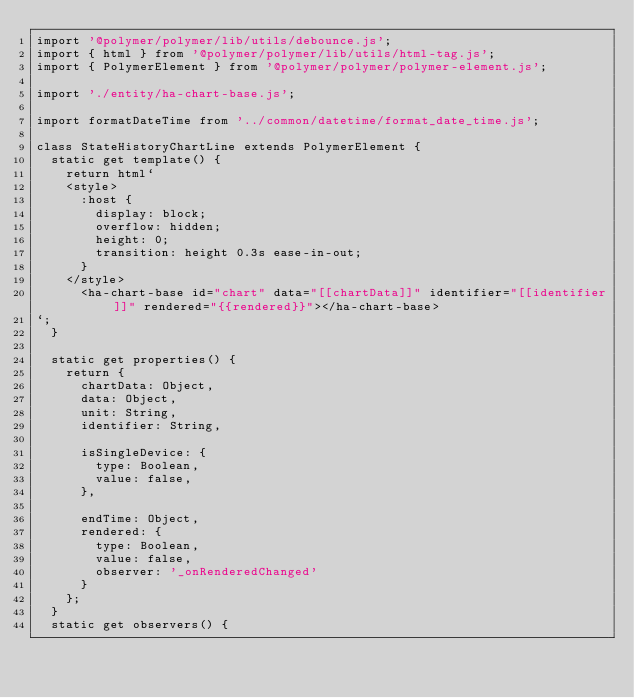<code> <loc_0><loc_0><loc_500><loc_500><_JavaScript_>import '@polymer/polymer/lib/utils/debounce.js';
import { html } from '@polymer/polymer/lib/utils/html-tag.js';
import { PolymerElement } from '@polymer/polymer/polymer-element.js';

import './entity/ha-chart-base.js';

import formatDateTime from '../common/datetime/format_date_time.js';

class StateHistoryChartLine extends PolymerElement {
  static get template() {
    return html`
    <style>
      :host {
        display: block;
        overflow: hidden;
        height: 0;
        transition: height 0.3s ease-in-out;
      }
    </style>
      <ha-chart-base id="chart" data="[[chartData]]" identifier="[[identifier]]" rendered="{{rendered}}"></ha-chart-base>
`;
  }

  static get properties() {
    return {
      chartData: Object,
      data: Object,
      unit: String,
      identifier: String,

      isSingleDevice: {
        type: Boolean,
        value: false,
      },

      endTime: Object,
      rendered: {
        type: Boolean,
        value: false,
        observer: '_onRenderedChanged'
      }
    };
  }
  static get observers() {</code> 